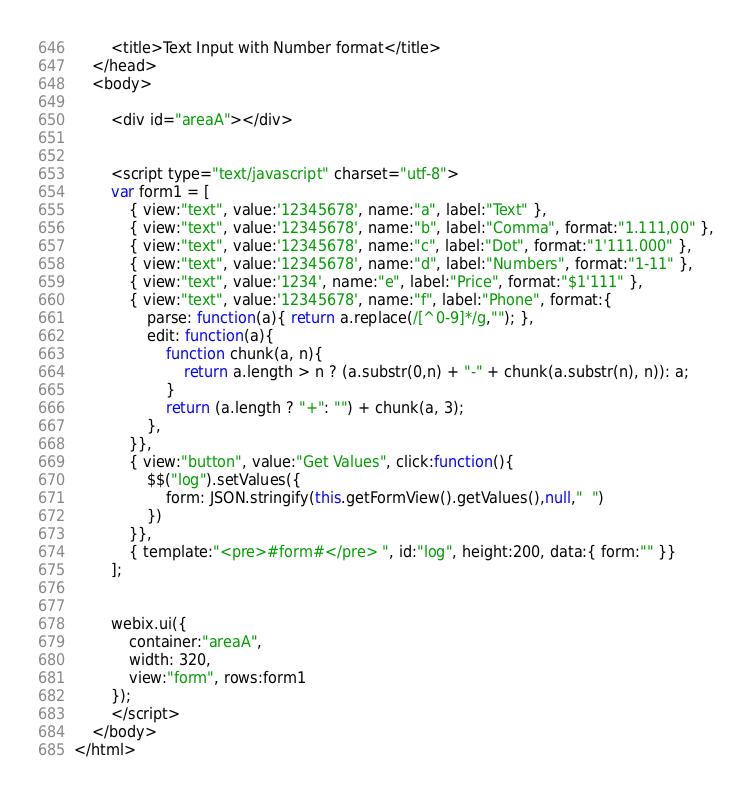Convert code to text. <code><loc_0><loc_0><loc_500><loc_500><_HTML_>		<title>Text Input with Number format</title>
	</head>
	<body>

		<div id="areaA"></div>
	

		<script type="text/javascript" charset="utf-8">
		var form1 = [
			{ view:"text", value:'12345678', name:"a", label:"Text" },
			{ view:"text", value:'12345678', name:"b", label:"Comma", format:"1.111,00" },
			{ view:"text", value:'12345678', name:"c", label:"Dot", format:"1'111.000" },
			{ view:"text", value:'12345678', name:"d", label:"Numbers", format:"1-11" },
			{ view:"text", value:'1234', name:"e", label:"Price", format:"$1'111" },
			{ view:"text", value:'12345678', name:"f", label:"Phone", format:{
				parse: function(a){ return a.replace(/[^0-9]*/g,""); },
				edit: function(a){ 
					function chunk(a, n){ 
						return a.length > n ? (a.substr(0,n) + "-" + chunk(a.substr(n), n)): a;
					}
					return (a.length ? "+": "") + chunk(a, 3);
				},
			}},
			{ view:"button", value:"Get Values", click:function(){
				$$("log").setValues({
					form: JSON.stringify(this.getFormView().getValues(),null,"  ")
				})
			}},
			{ template:"<pre>#form#</pre> ", id:"log", height:200, data:{ form:"" }}
		];


		webix.ui({
			container:"areaA",
			width: 320,
			view:"form", rows:form1
		});
		</script>
	</body>
</html></code> 